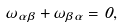Convert formula to latex. <formula><loc_0><loc_0><loc_500><loc_500>\omega _ { \alpha \beta } + \omega _ { \beta \alpha } = 0 ,</formula> 